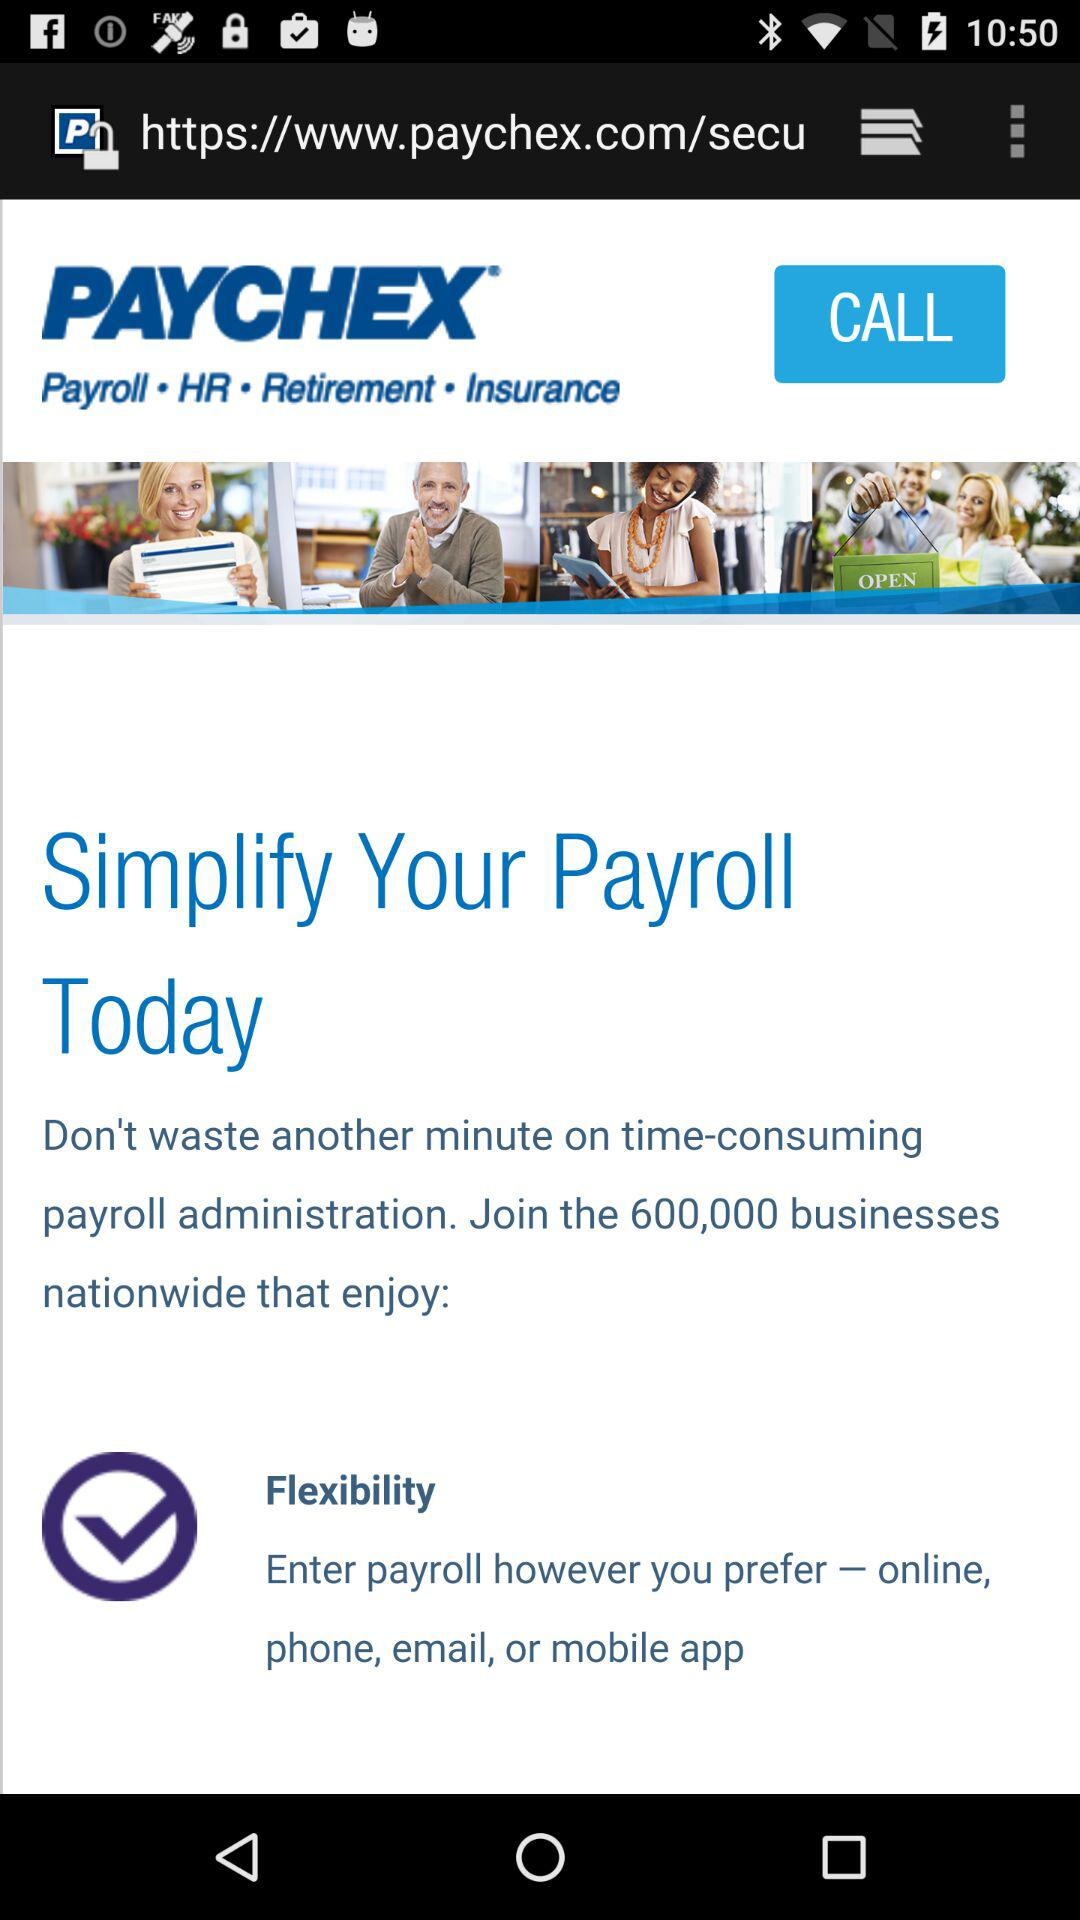How many people are joined paychex?
When the provided information is insufficient, respond with <no answer>. <no answer> 